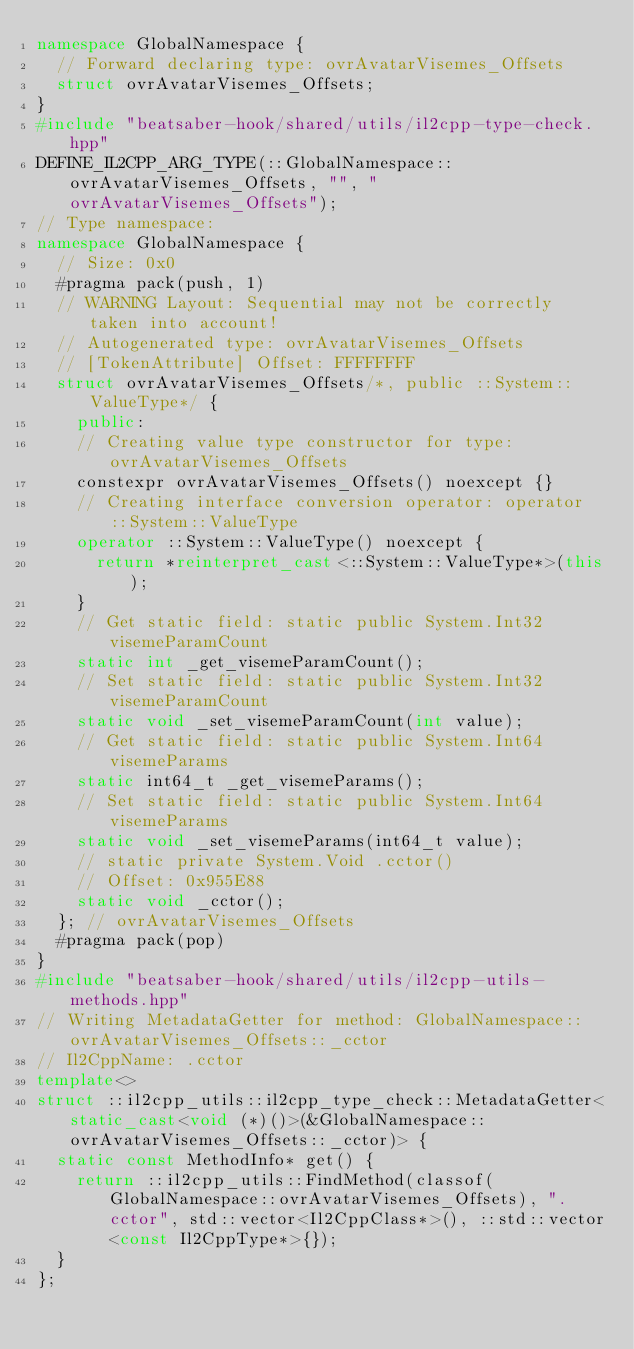<code> <loc_0><loc_0><loc_500><loc_500><_C++_>namespace GlobalNamespace {
  // Forward declaring type: ovrAvatarVisemes_Offsets
  struct ovrAvatarVisemes_Offsets;
}
#include "beatsaber-hook/shared/utils/il2cpp-type-check.hpp"
DEFINE_IL2CPP_ARG_TYPE(::GlobalNamespace::ovrAvatarVisemes_Offsets, "", "ovrAvatarVisemes_Offsets");
// Type namespace: 
namespace GlobalNamespace {
  // Size: 0x0
  #pragma pack(push, 1)
  // WARNING Layout: Sequential may not be correctly taken into account!
  // Autogenerated type: ovrAvatarVisemes_Offsets
  // [TokenAttribute] Offset: FFFFFFFF
  struct ovrAvatarVisemes_Offsets/*, public ::System::ValueType*/ {
    public:
    // Creating value type constructor for type: ovrAvatarVisemes_Offsets
    constexpr ovrAvatarVisemes_Offsets() noexcept {}
    // Creating interface conversion operator: operator ::System::ValueType
    operator ::System::ValueType() noexcept {
      return *reinterpret_cast<::System::ValueType*>(this);
    }
    // Get static field: static public System.Int32 visemeParamCount
    static int _get_visemeParamCount();
    // Set static field: static public System.Int32 visemeParamCount
    static void _set_visemeParamCount(int value);
    // Get static field: static public System.Int64 visemeParams
    static int64_t _get_visemeParams();
    // Set static field: static public System.Int64 visemeParams
    static void _set_visemeParams(int64_t value);
    // static private System.Void .cctor()
    // Offset: 0x955E88
    static void _cctor();
  }; // ovrAvatarVisemes_Offsets
  #pragma pack(pop)
}
#include "beatsaber-hook/shared/utils/il2cpp-utils-methods.hpp"
// Writing MetadataGetter for method: GlobalNamespace::ovrAvatarVisemes_Offsets::_cctor
// Il2CppName: .cctor
template<>
struct ::il2cpp_utils::il2cpp_type_check::MetadataGetter<static_cast<void (*)()>(&GlobalNamespace::ovrAvatarVisemes_Offsets::_cctor)> {
  static const MethodInfo* get() {
    return ::il2cpp_utils::FindMethod(classof(GlobalNamespace::ovrAvatarVisemes_Offsets), ".cctor", std::vector<Il2CppClass*>(), ::std::vector<const Il2CppType*>{});
  }
};
</code> 